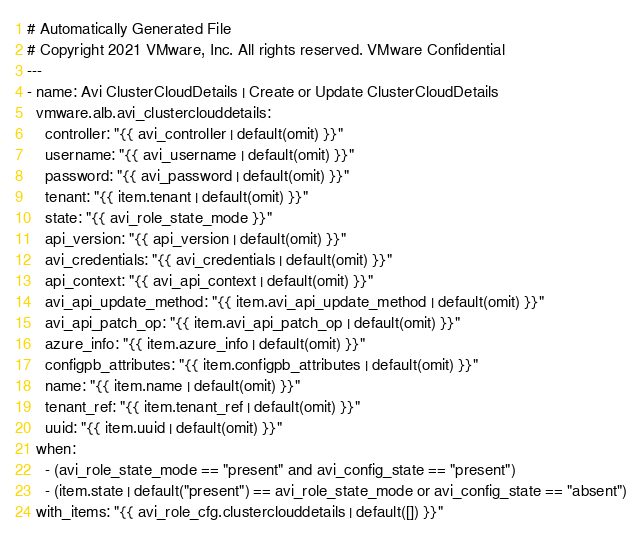<code> <loc_0><loc_0><loc_500><loc_500><_YAML_># Automatically Generated File
# Copyright 2021 VMware, Inc. All rights reserved. VMware Confidential
---
- name: Avi ClusterCloudDetails | Create or Update ClusterCloudDetails
  vmware.alb.avi_clusterclouddetails:
    controller: "{{ avi_controller | default(omit) }}"
    username: "{{ avi_username | default(omit) }}"
    password: "{{ avi_password | default(omit) }}"
    tenant: "{{ item.tenant | default(omit) }}"
    state: "{{ avi_role_state_mode }}"
    api_version: "{{ api_version | default(omit) }}"
    avi_credentials: "{{ avi_credentials | default(omit) }}"
    api_context: "{{ avi_api_context | default(omit) }}"
    avi_api_update_method: "{{ item.avi_api_update_method | default(omit) }}"
    avi_api_patch_op: "{{ item.avi_api_patch_op | default(omit) }}"
    azure_info: "{{ item.azure_info | default(omit) }}"
    configpb_attributes: "{{ item.configpb_attributes | default(omit) }}"
    name: "{{ item.name | default(omit) }}"
    tenant_ref: "{{ item.tenant_ref | default(omit) }}"
    uuid: "{{ item.uuid | default(omit) }}"
  when:
    - (avi_role_state_mode == "present" and avi_config_state == "present")
    - (item.state | default("present") == avi_role_state_mode or avi_config_state == "absent")
  with_items: "{{ avi_role_cfg.clusterclouddetails | default([]) }}"
</code> 